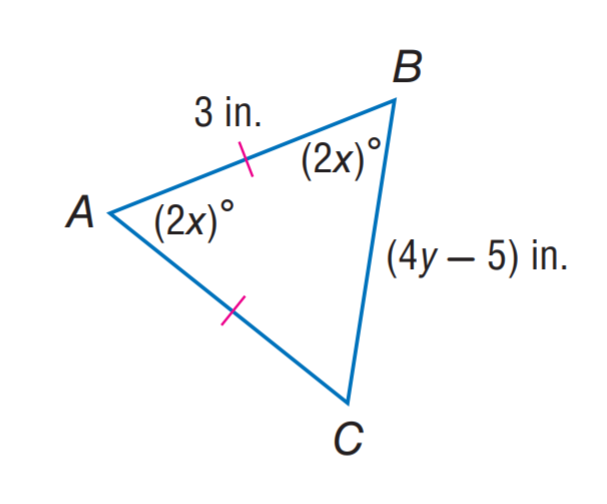Answer the mathemtical geometry problem and directly provide the correct option letter.
Question: Find y.
Choices: A: 1 B: 2 C: 3 D: 4 B 